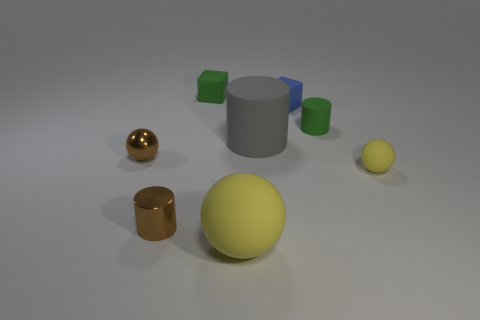What is the tiny blue thing made of?
Ensure brevity in your answer.  Rubber. Are there more small green matte things that are in front of the brown metal cylinder than balls?
Your answer should be compact. No. Are any big rubber cylinders visible?
Ensure brevity in your answer.  Yes. How many other objects are the same shape as the gray object?
Give a very brief answer. 2. Does the small matte cube that is behind the tiny blue matte cube have the same color as the matte ball in front of the tiny brown metal cylinder?
Ensure brevity in your answer.  No. There is a matte sphere that is to the left of the green rubber object in front of the rubber cube to the right of the big yellow ball; what is its size?
Give a very brief answer. Large. What shape is the object that is in front of the small yellow sphere and behind the large yellow matte object?
Give a very brief answer. Cylinder. Are there the same number of tiny shiny cylinders in front of the green rubber cube and matte cubes on the left side of the gray matte cylinder?
Offer a very short reply. Yes. Is there a green cube made of the same material as the blue object?
Provide a short and direct response. Yes. Is the material of the brown thing that is behind the metal cylinder the same as the gray thing?
Your response must be concise. No. 